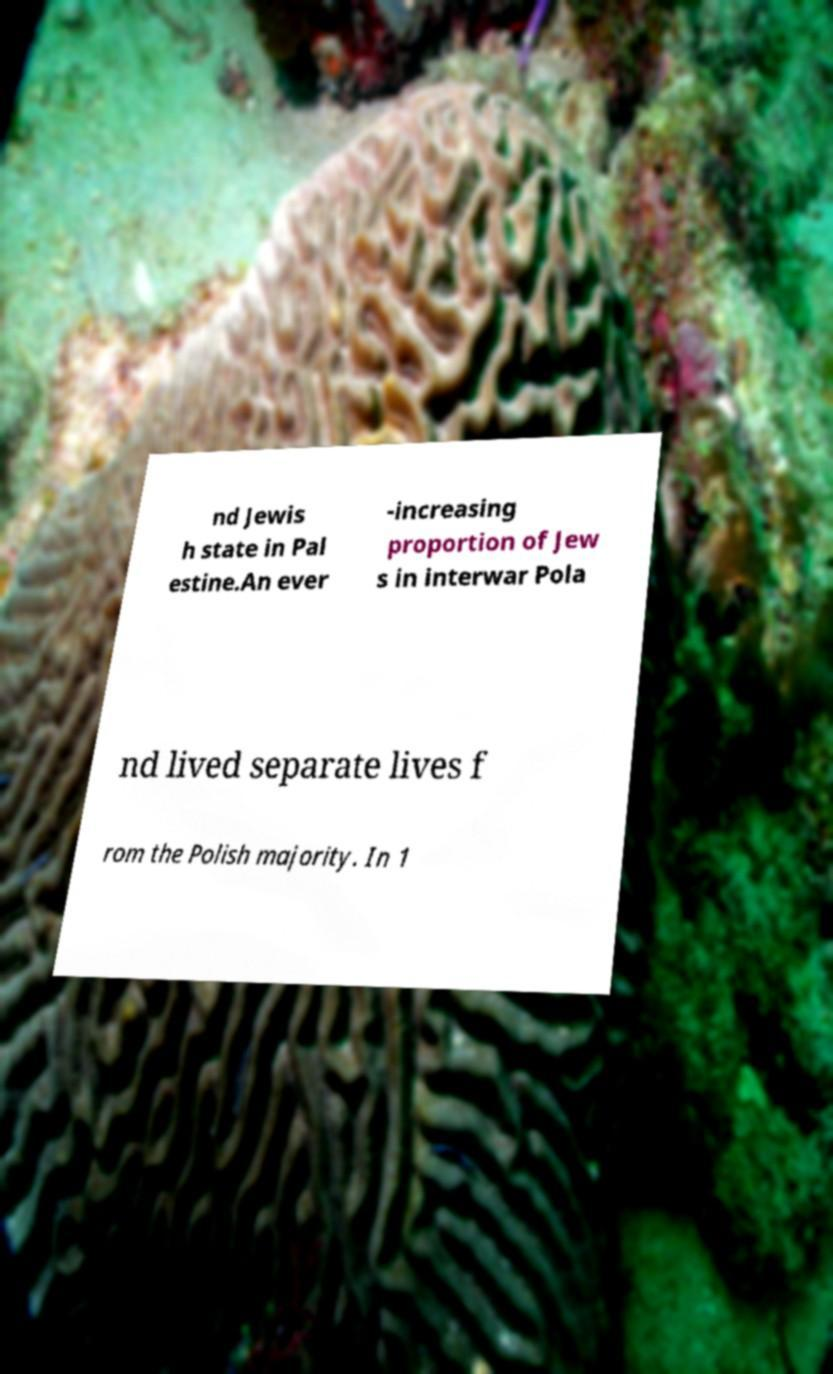Could you extract and type out the text from this image? nd Jewis h state in Pal estine.An ever -increasing proportion of Jew s in interwar Pola nd lived separate lives f rom the Polish majority. In 1 